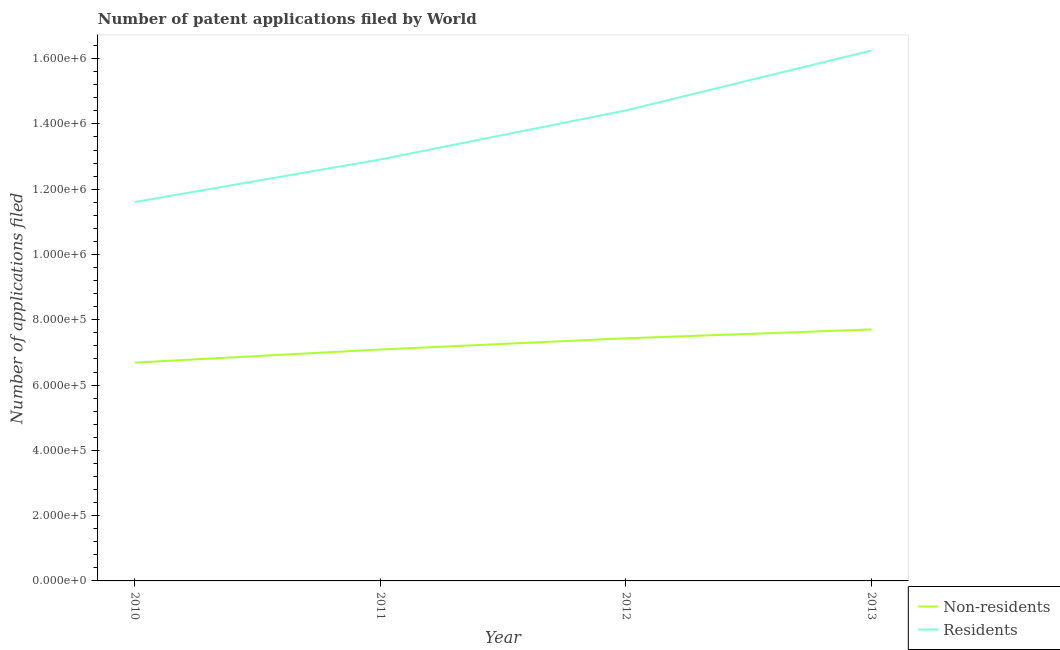How many different coloured lines are there?
Keep it short and to the point. 2. Does the line corresponding to number of patent applications by residents intersect with the line corresponding to number of patent applications by non residents?
Provide a short and direct response. No. Is the number of lines equal to the number of legend labels?
Ensure brevity in your answer.  Yes. What is the number of patent applications by non residents in 2011?
Provide a short and direct response. 7.09e+05. Across all years, what is the maximum number of patent applications by residents?
Offer a very short reply. 1.62e+06. Across all years, what is the minimum number of patent applications by residents?
Provide a short and direct response. 1.16e+06. In which year was the number of patent applications by residents maximum?
Your answer should be compact. 2013. What is the total number of patent applications by non residents in the graph?
Provide a short and direct response. 2.89e+06. What is the difference between the number of patent applications by residents in 2010 and that in 2011?
Your response must be concise. -1.30e+05. What is the difference between the number of patent applications by non residents in 2011 and the number of patent applications by residents in 2012?
Your answer should be compact. -7.32e+05. What is the average number of patent applications by non residents per year?
Make the answer very short. 7.23e+05. In the year 2011, what is the difference between the number of patent applications by non residents and number of patent applications by residents?
Offer a very short reply. -5.82e+05. In how many years, is the number of patent applications by non residents greater than 520000?
Your response must be concise. 4. What is the ratio of the number of patent applications by non residents in 2010 to that in 2012?
Provide a short and direct response. 0.9. Is the number of patent applications by non residents in 2010 less than that in 2012?
Give a very brief answer. Yes. What is the difference between the highest and the second highest number of patent applications by residents?
Offer a terse response. 1.84e+05. What is the difference between the highest and the lowest number of patent applications by non residents?
Ensure brevity in your answer.  1.01e+05. In how many years, is the number of patent applications by residents greater than the average number of patent applications by residents taken over all years?
Give a very brief answer. 2. Are the values on the major ticks of Y-axis written in scientific E-notation?
Give a very brief answer. Yes. Does the graph contain any zero values?
Offer a very short reply. No. Does the graph contain grids?
Provide a short and direct response. No. How are the legend labels stacked?
Give a very brief answer. Vertical. What is the title of the graph?
Offer a terse response. Number of patent applications filed by World. What is the label or title of the Y-axis?
Your response must be concise. Number of applications filed. What is the Number of applications filed of Non-residents in 2010?
Give a very brief answer. 6.69e+05. What is the Number of applications filed in Residents in 2010?
Give a very brief answer. 1.16e+06. What is the Number of applications filed of Non-residents in 2011?
Offer a very short reply. 7.09e+05. What is the Number of applications filed of Residents in 2011?
Make the answer very short. 1.29e+06. What is the Number of applications filed of Non-residents in 2012?
Offer a terse response. 7.43e+05. What is the Number of applications filed of Residents in 2012?
Offer a terse response. 1.44e+06. What is the Number of applications filed of Non-residents in 2013?
Keep it short and to the point. 7.70e+05. What is the Number of applications filed in Residents in 2013?
Offer a terse response. 1.62e+06. Across all years, what is the maximum Number of applications filed in Non-residents?
Offer a terse response. 7.70e+05. Across all years, what is the maximum Number of applications filed in Residents?
Your response must be concise. 1.62e+06. Across all years, what is the minimum Number of applications filed in Non-residents?
Make the answer very short. 6.69e+05. Across all years, what is the minimum Number of applications filed in Residents?
Provide a short and direct response. 1.16e+06. What is the total Number of applications filed in Non-residents in the graph?
Provide a succinct answer. 2.89e+06. What is the total Number of applications filed of Residents in the graph?
Make the answer very short. 5.52e+06. What is the difference between the Number of applications filed in Non-residents in 2010 and that in 2011?
Provide a short and direct response. -4.01e+04. What is the difference between the Number of applications filed in Residents in 2010 and that in 2011?
Your response must be concise. -1.30e+05. What is the difference between the Number of applications filed in Non-residents in 2010 and that in 2012?
Offer a very short reply. -7.44e+04. What is the difference between the Number of applications filed of Residents in 2010 and that in 2012?
Your answer should be compact. -2.81e+05. What is the difference between the Number of applications filed of Non-residents in 2010 and that in 2013?
Ensure brevity in your answer.  -1.01e+05. What is the difference between the Number of applications filed in Residents in 2010 and that in 2013?
Make the answer very short. -4.64e+05. What is the difference between the Number of applications filed in Non-residents in 2011 and that in 2012?
Your answer should be very brief. -3.43e+04. What is the difference between the Number of applications filed of Residents in 2011 and that in 2012?
Your answer should be very brief. -1.50e+05. What is the difference between the Number of applications filed in Non-residents in 2011 and that in 2013?
Your answer should be very brief. -6.13e+04. What is the difference between the Number of applications filed of Residents in 2011 and that in 2013?
Your answer should be very brief. -3.34e+05. What is the difference between the Number of applications filed of Non-residents in 2012 and that in 2013?
Ensure brevity in your answer.  -2.70e+04. What is the difference between the Number of applications filed of Residents in 2012 and that in 2013?
Ensure brevity in your answer.  -1.84e+05. What is the difference between the Number of applications filed of Non-residents in 2010 and the Number of applications filed of Residents in 2011?
Your answer should be compact. -6.22e+05. What is the difference between the Number of applications filed of Non-residents in 2010 and the Number of applications filed of Residents in 2012?
Give a very brief answer. -7.73e+05. What is the difference between the Number of applications filed in Non-residents in 2010 and the Number of applications filed in Residents in 2013?
Give a very brief answer. -9.56e+05. What is the difference between the Number of applications filed in Non-residents in 2011 and the Number of applications filed in Residents in 2012?
Ensure brevity in your answer.  -7.32e+05. What is the difference between the Number of applications filed in Non-residents in 2011 and the Number of applications filed in Residents in 2013?
Your answer should be compact. -9.16e+05. What is the difference between the Number of applications filed of Non-residents in 2012 and the Number of applications filed of Residents in 2013?
Offer a very short reply. -8.82e+05. What is the average Number of applications filed of Non-residents per year?
Offer a very short reply. 7.23e+05. What is the average Number of applications filed of Residents per year?
Provide a short and direct response. 1.38e+06. In the year 2010, what is the difference between the Number of applications filed of Non-residents and Number of applications filed of Residents?
Ensure brevity in your answer.  -4.92e+05. In the year 2011, what is the difference between the Number of applications filed of Non-residents and Number of applications filed of Residents?
Provide a succinct answer. -5.82e+05. In the year 2012, what is the difference between the Number of applications filed of Non-residents and Number of applications filed of Residents?
Your answer should be very brief. -6.98e+05. In the year 2013, what is the difference between the Number of applications filed of Non-residents and Number of applications filed of Residents?
Ensure brevity in your answer.  -8.55e+05. What is the ratio of the Number of applications filed in Non-residents in 2010 to that in 2011?
Your response must be concise. 0.94. What is the ratio of the Number of applications filed in Residents in 2010 to that in 2011?
Offer a very short reply. 0.9. What is the ratio of the Number of applications filed in Non-residents in 2010 to that in 2012?
Provide a succinct answer. 0.9. What is the ratio of the Number of applications filed of Residents in 2010 to that in 2012?
Keep it short and to the point. 0.81. What is the ratio of the Number of applications filed of Non-residents in 2010 to that in 2013?
Offer a terse response. 0.87. What is the ratio of the Number of applications filed of Non-residents in 2011 to that in 2012?
Provide a short and direct response. 0.95. What is the ratio of the Number of applications filed of Residents in 2011 to that in 2012?
Keep it short and to the point. 0.9. What is the ratio of the Number of applications filed in Non-residents in 2011 to that in 2013?
Your answer should be compact. 0.92. What is the ratio of the Number of applications filed in Residents in 2011 to that in 2013?
Offer a very short reply. 0.79. What is the ratio of the Number of applications filed of Non-residents in 2012 to that in 2013?
Your answer should be compact. 0.96. What is the ratio of the Number of applications filed of Residents in 2012 to that in 2013?
Make the answer very short. 0.89. What is the difference between the highest and the second highest Number of applications filed of Non-residents?
Provide a succinct answer. 2.70e+04. What is the difference between the highest and the second highest Number of applications filed in Residents?
Your response must be concise. 1.84e+05. What is the difference between the highest and the lowest Number of applications filed of Non-residents?
Keep it short and to the point. 1.01e+05. What is the difference between the highest and the lowest Number of applications filed of Residents?
Your answer should be compact. 4.64e+05. 